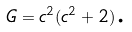<formula> <loc_0><loc_0><loc_500><loc_500>G = c ^ { 2 } ( c ^ { 2 } + 2 ) \text {.}</formula> 